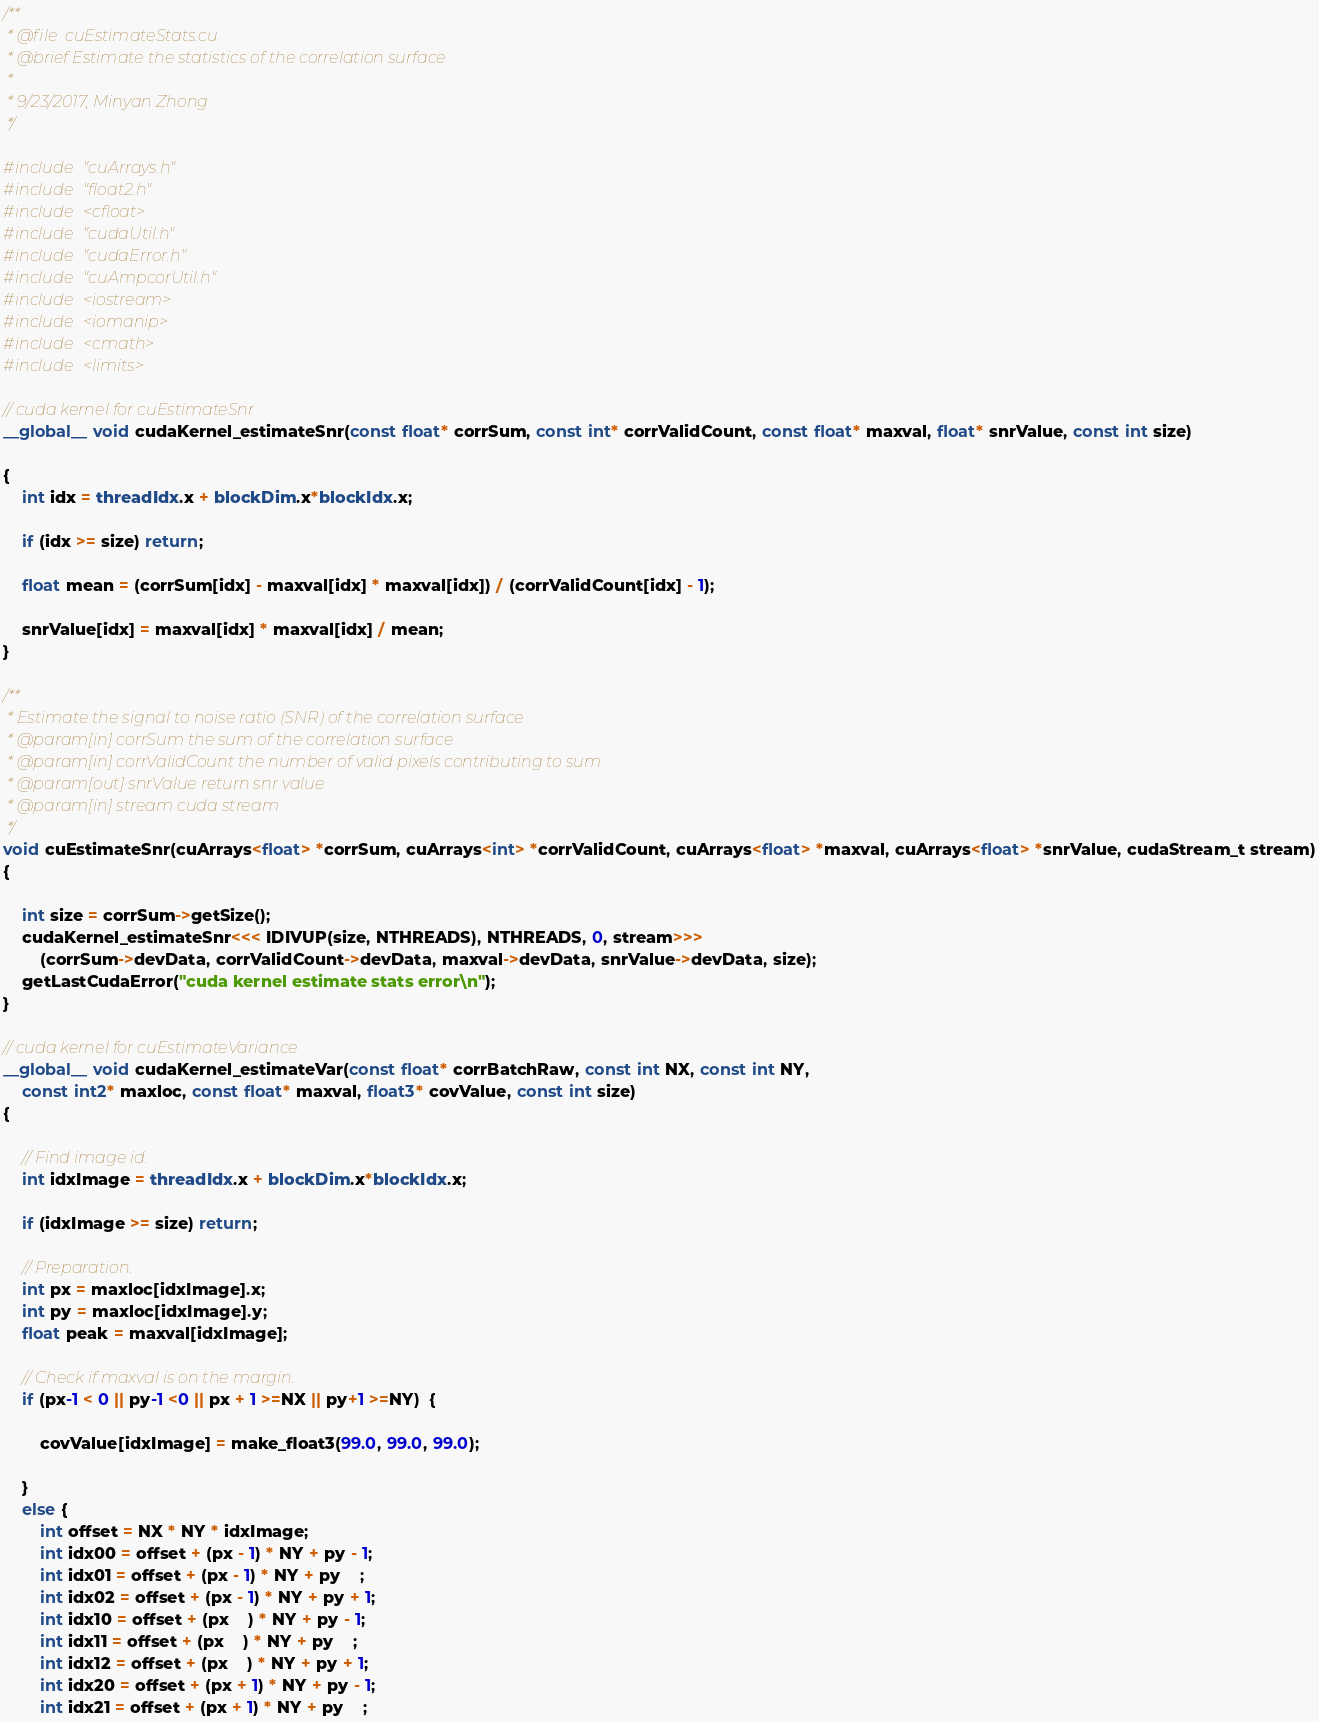Convert code to text. <code><loc_0><loc_0><loc_500><loc_500><_Cuda_>/**
 * @file  cuEstimateStats.cu
 * @brief Estimate the statistics of the correlation surface
 *
 * 9/23/2017, Minyan Zhong
 */

#include "cuArrays.h"
#include "float2.h"
#include <cfloat>
#include "cudaUtil.h"
#include "cudaError.h"
#include "cuAmpcorUtil.h"
#include <iostream>
#include <iomanip>
#include <cmath>
#include <limits>

// cuda kernel for cuEstimateSnr
__global__ void cudaKernel_estimateSnr(const float* corrSum, const int* corrValidCount, const float* maxval, float* snrValue, const int size)

{
    int idx = threadIdx.x + blockDim.x*blockIdx.x;

    if (idx >= size) return;

    float mean = (corrSum[idx] - maxval[idx] * maxval[idx]) / (corrValidCount[idx] - 1);

    snrValue[idx] = maxval[idx] * maxval[idx] / mean;
}

/**
 * Estimate the signal to noise ratio (SNR) of the correlation surface
 * @param[in] corrSum the sum of the correlation surface
 * @param[in] corrValidCount the number of valid pixels contributing to sum
 * @param[out] snrValue return snr value
 * @param[in] stream cuda stream
 */
void cuEstimateSnr(cuArrays<float> *corrSum, cuArrays<int> *corrValidCount, cuArrays<float> *maxval, cuArrays<float> *snrValue, cudaStream_t stream)
{

    int size = corrSum->getSize();
    cudaKernel_estimateSnr<<< IDIVUP(size, NTHREADS), NTHREADS, 0, stream>>>
        (corrSum->devData, corrValidCount->devData, maxval->devData, snrValue->devData, size);
    getLastCudaError("cuda kernel estimate stats error\n");
}

// cuda kernel for cuEstimateVariance
__global__ void cudaKernel_estimateVar(const float* corrBatchRaw, const int NX, const int NY,
    const int2* maxloc, const float* maxval, float3* covValue, const int size)
{

    // Find image id.
    int idxImage = threadIdx.x + blockDim.x*blockIdx.x;

    if (idxImage >= size) return;

    // Preparation.
    int px = maxloc[idxImage].x;
    int py = maxloc[idxImage].y;
    float peak = maxval[idxImage];

    // Check if maxval is on the margin.
    if (px-1 < 0 || py-1 <0 || px + 1 >=NX || py+1 >=NY)  {

        covValue[idxImage] = make_float3(99.0, 99.0, 99.0);

    }
    else {
        int offset = NX * NY * idxImage;
        int idx00 = offset + (px - 1) * NY + py - 1;
        int idx01 = offset + (px - 1) * NY + py    ;
        int idx02 = offset + (px - 1) * NY + py + 1;
        int idx10 = offset + (px    ) * NY + py - 1;
        int idx11 = offset + (px    ) * NY + py    ;
        int idx12 = offset + (px    ) * NY + py + 1;
        int idx20 = offset + (px + 1) * NY + py - 1;
        int idx21 = offset + (px + 1) * NY + py    ;</code> 